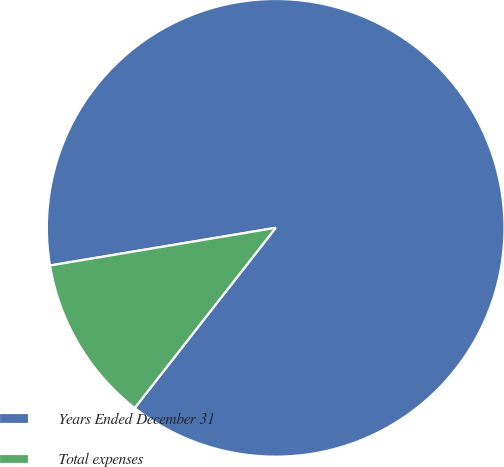<chart> <loc_0><loc_0><loc_500><loc_500><pie_chart><fcel>Years Ended December 31<fcel>Total expenses<nl><fcel>88.2%<fcel>11.8%<nl></chart> 